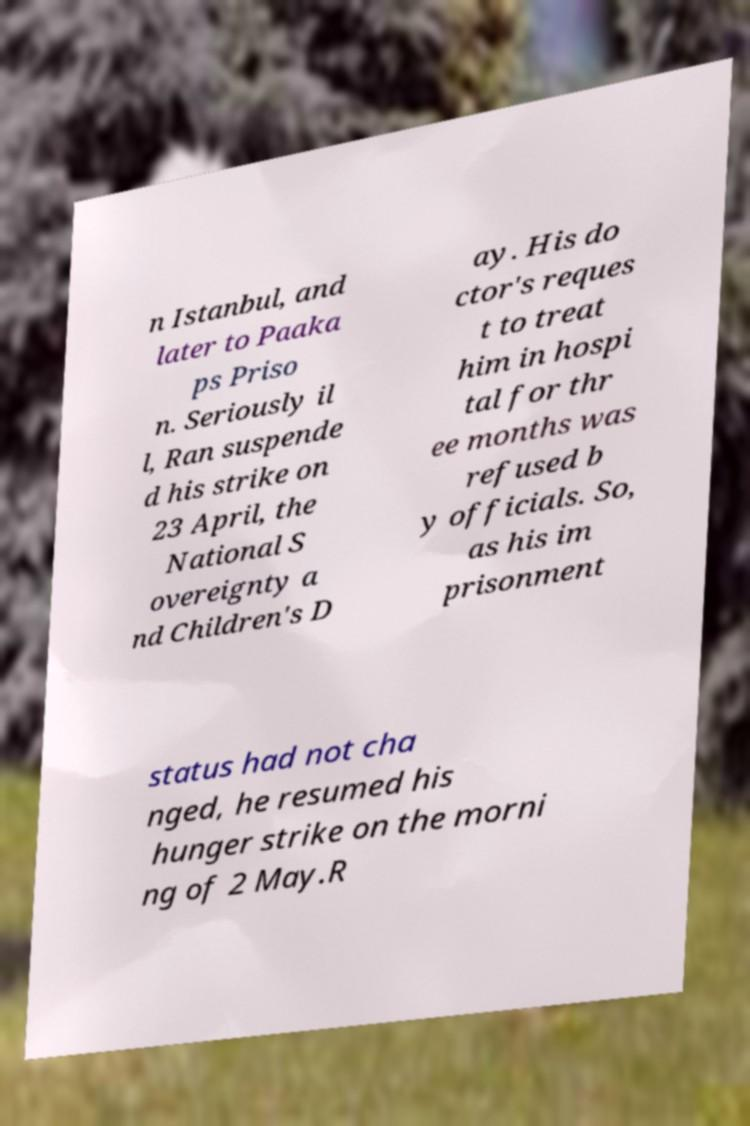What messages or text are displayed in this image? I need them in a readable, typed format. n Istanbul, and later to Paaka ps Priso n. Seriously il l, Ran suspende d his strike on 23 April, the National S overeignty a nd Children's D ay. His do ctor's reques t to treat him in hospi tal for thr ee months was refused b y officials. So, as his im prisonment status had not cha nged, he resumed his hunger strike on the morni ng of 2 May.R 